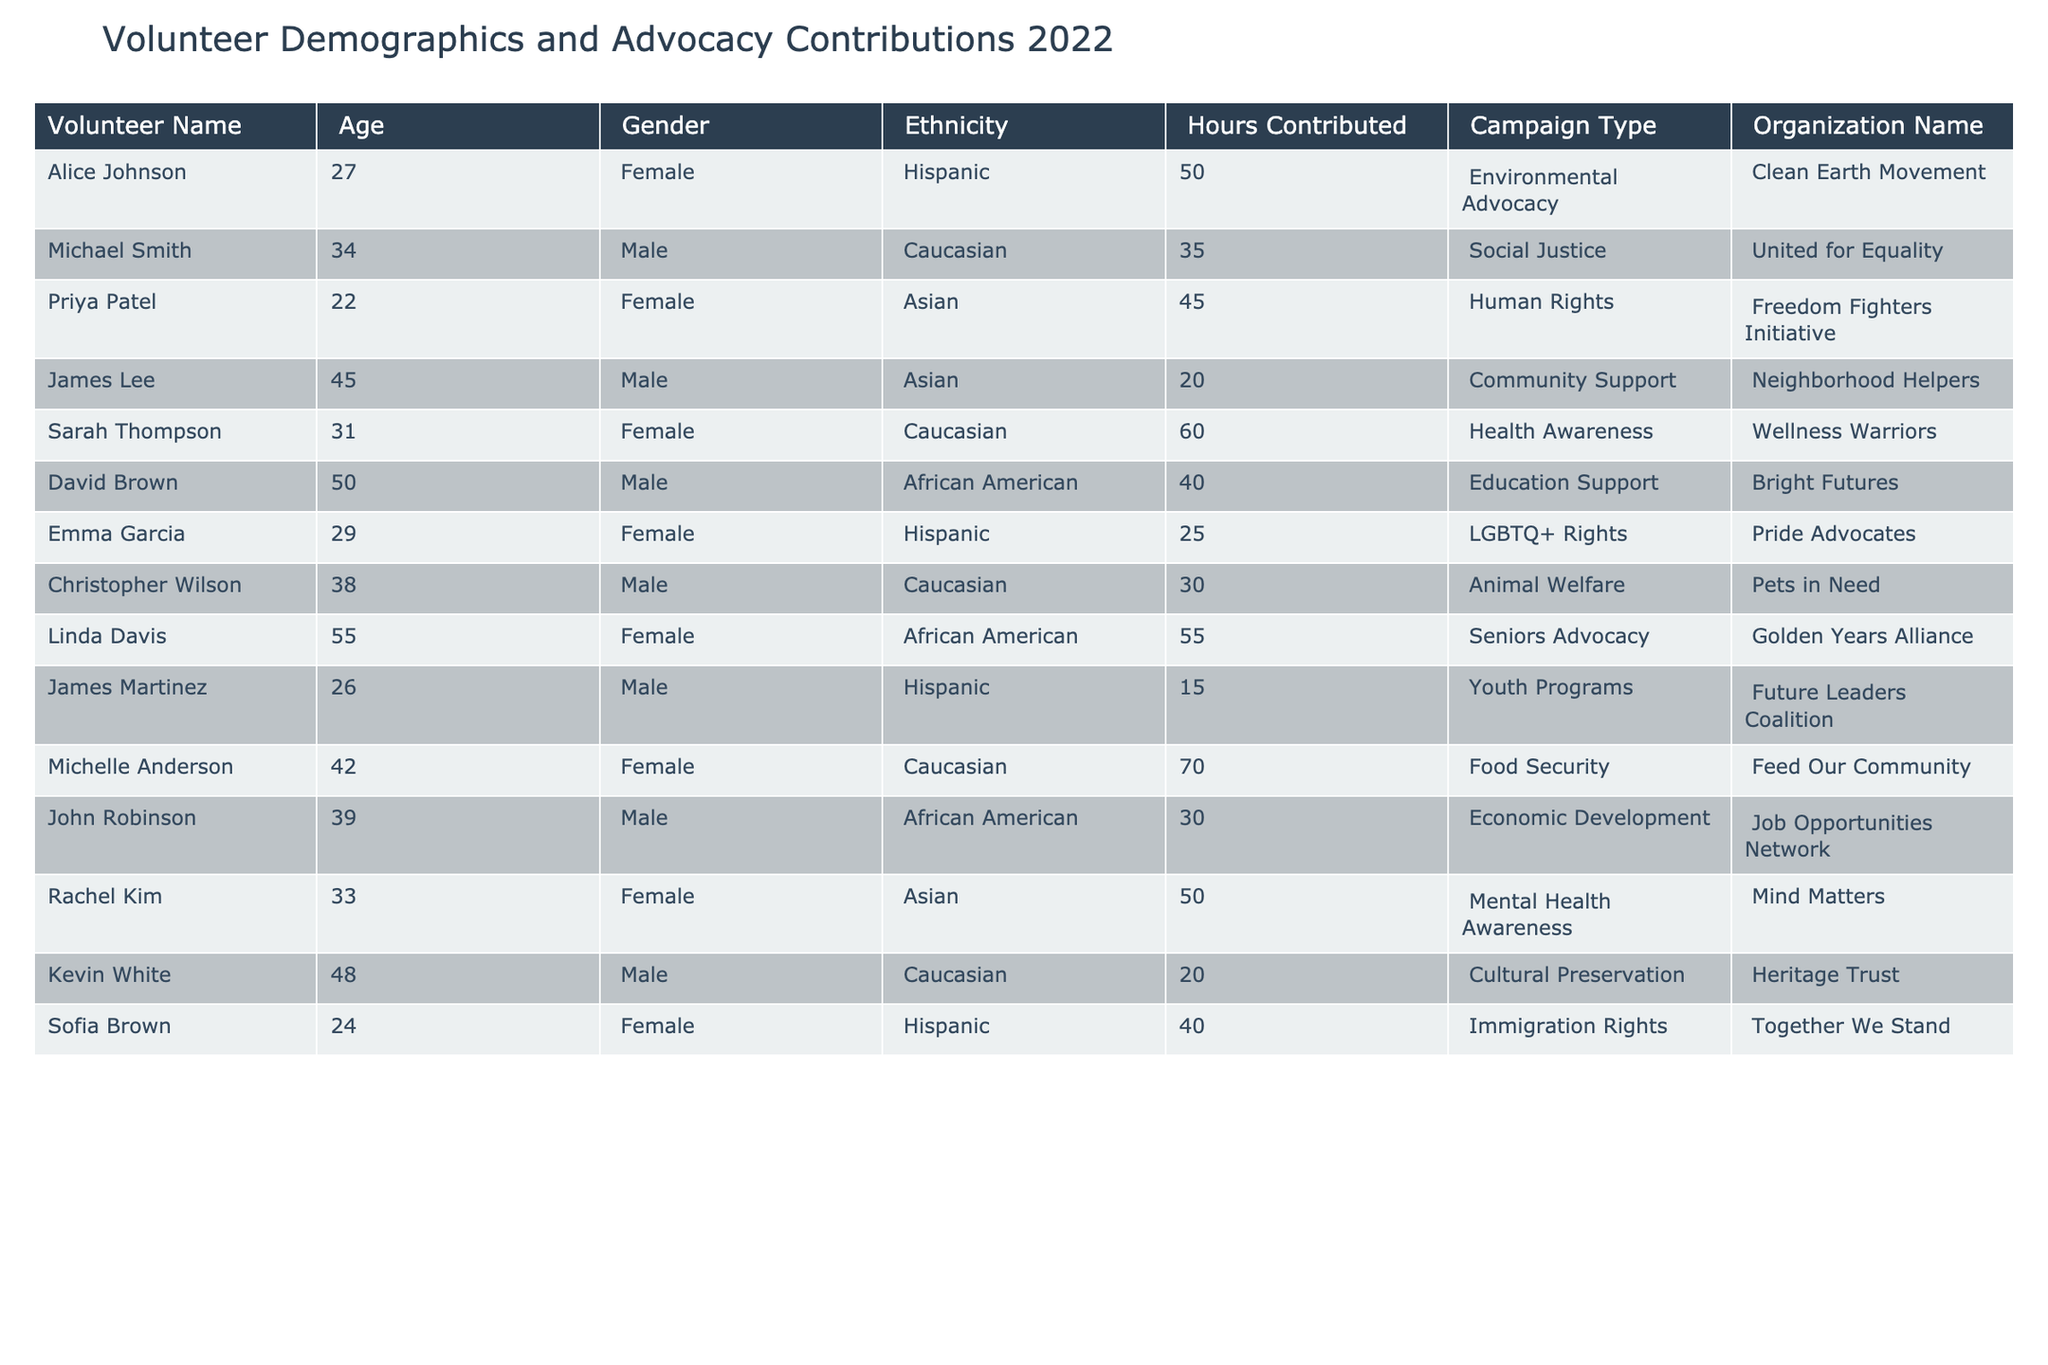What is the total number of hours contributed by volunteers from the Clean Earth Movement? The table shows that Alice Johnson contributed 50 hours to the Clean Earth Movement. Since she is the only volunteer listed for this organization, the total is simply her contribution: 50 hours.
Answer: 50 Which ethnicity contributed the most hours in total? To determine which ethnicity contributed the most hours, we need to sum the hours contributed by each ethnicity. The totals are as follows: Hispanic (50 + 25 + 15 + 40 = 130), Caucasian (35 + 60 + 70 + 30 = 195), Asian (45 + 20 + 50 = 115), African American (40 + 55 + 30 = 125). The highest total is for Caucasian with 195 hours.
Answer: Caucasian Is there a male volunteer who contributed more than 50 hours? Reviewing the contributions of male volunteers: Michael Smith (35), James Lee (20), David Brown (40), John Robinson (30), Kevin White (20), and there are no male volunteers with hours exceeding 50.
Answer: No What is the average number of hours contributed by Asian volunteers? The Asian volunteers are Priya Patel (45), James Lee (20), and Rachel Kim (50). To find the average, first sum the hours: 45 + 20 + 50 = 115. Then divide by the number of Asian volunteers (3): 115 / 3 = approximately 38.33.
Answer: Approximately 38.33 How many volunteers contributed to youth programs? Referring to the data, we see that James Martinez contributed to Youth Programs, and he is the only one listed under this category.
Answer: 1 